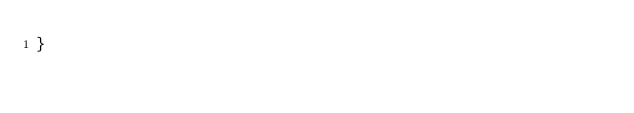Convert code to text. <code><loc_0><loc_0><loc_500><loc_500><_JavaScript_>}</code> 